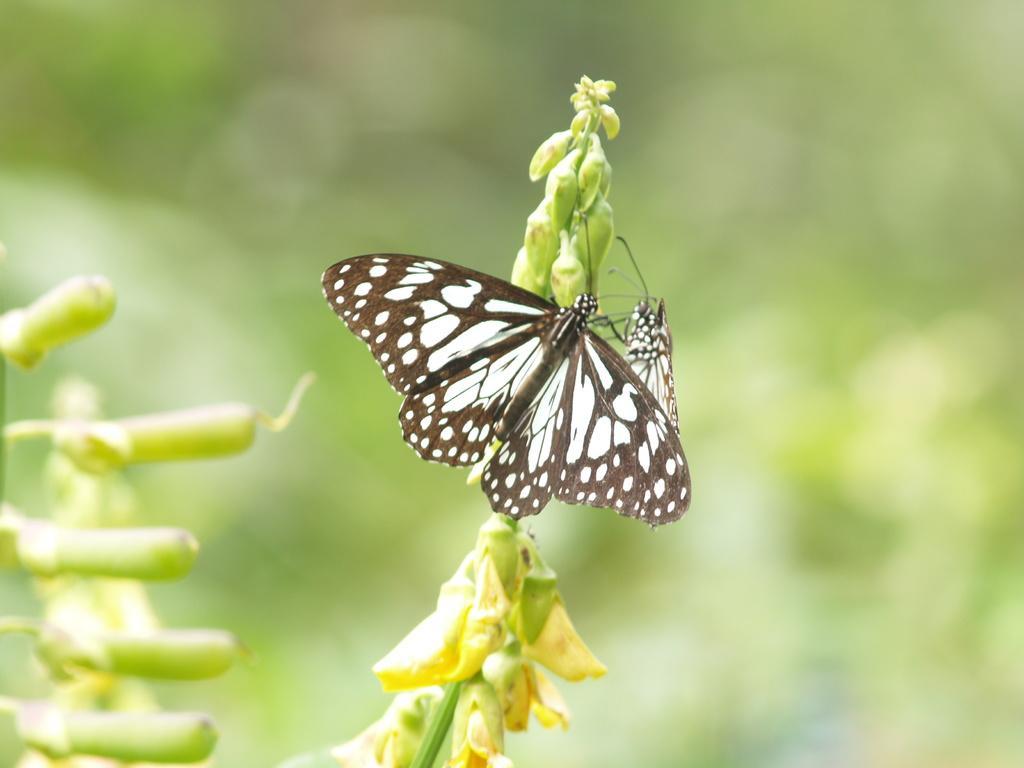Can you describe this image briefly? In the image in the center we can see one plant. On the plant,we can see two butterflies,which are in black and white color. 